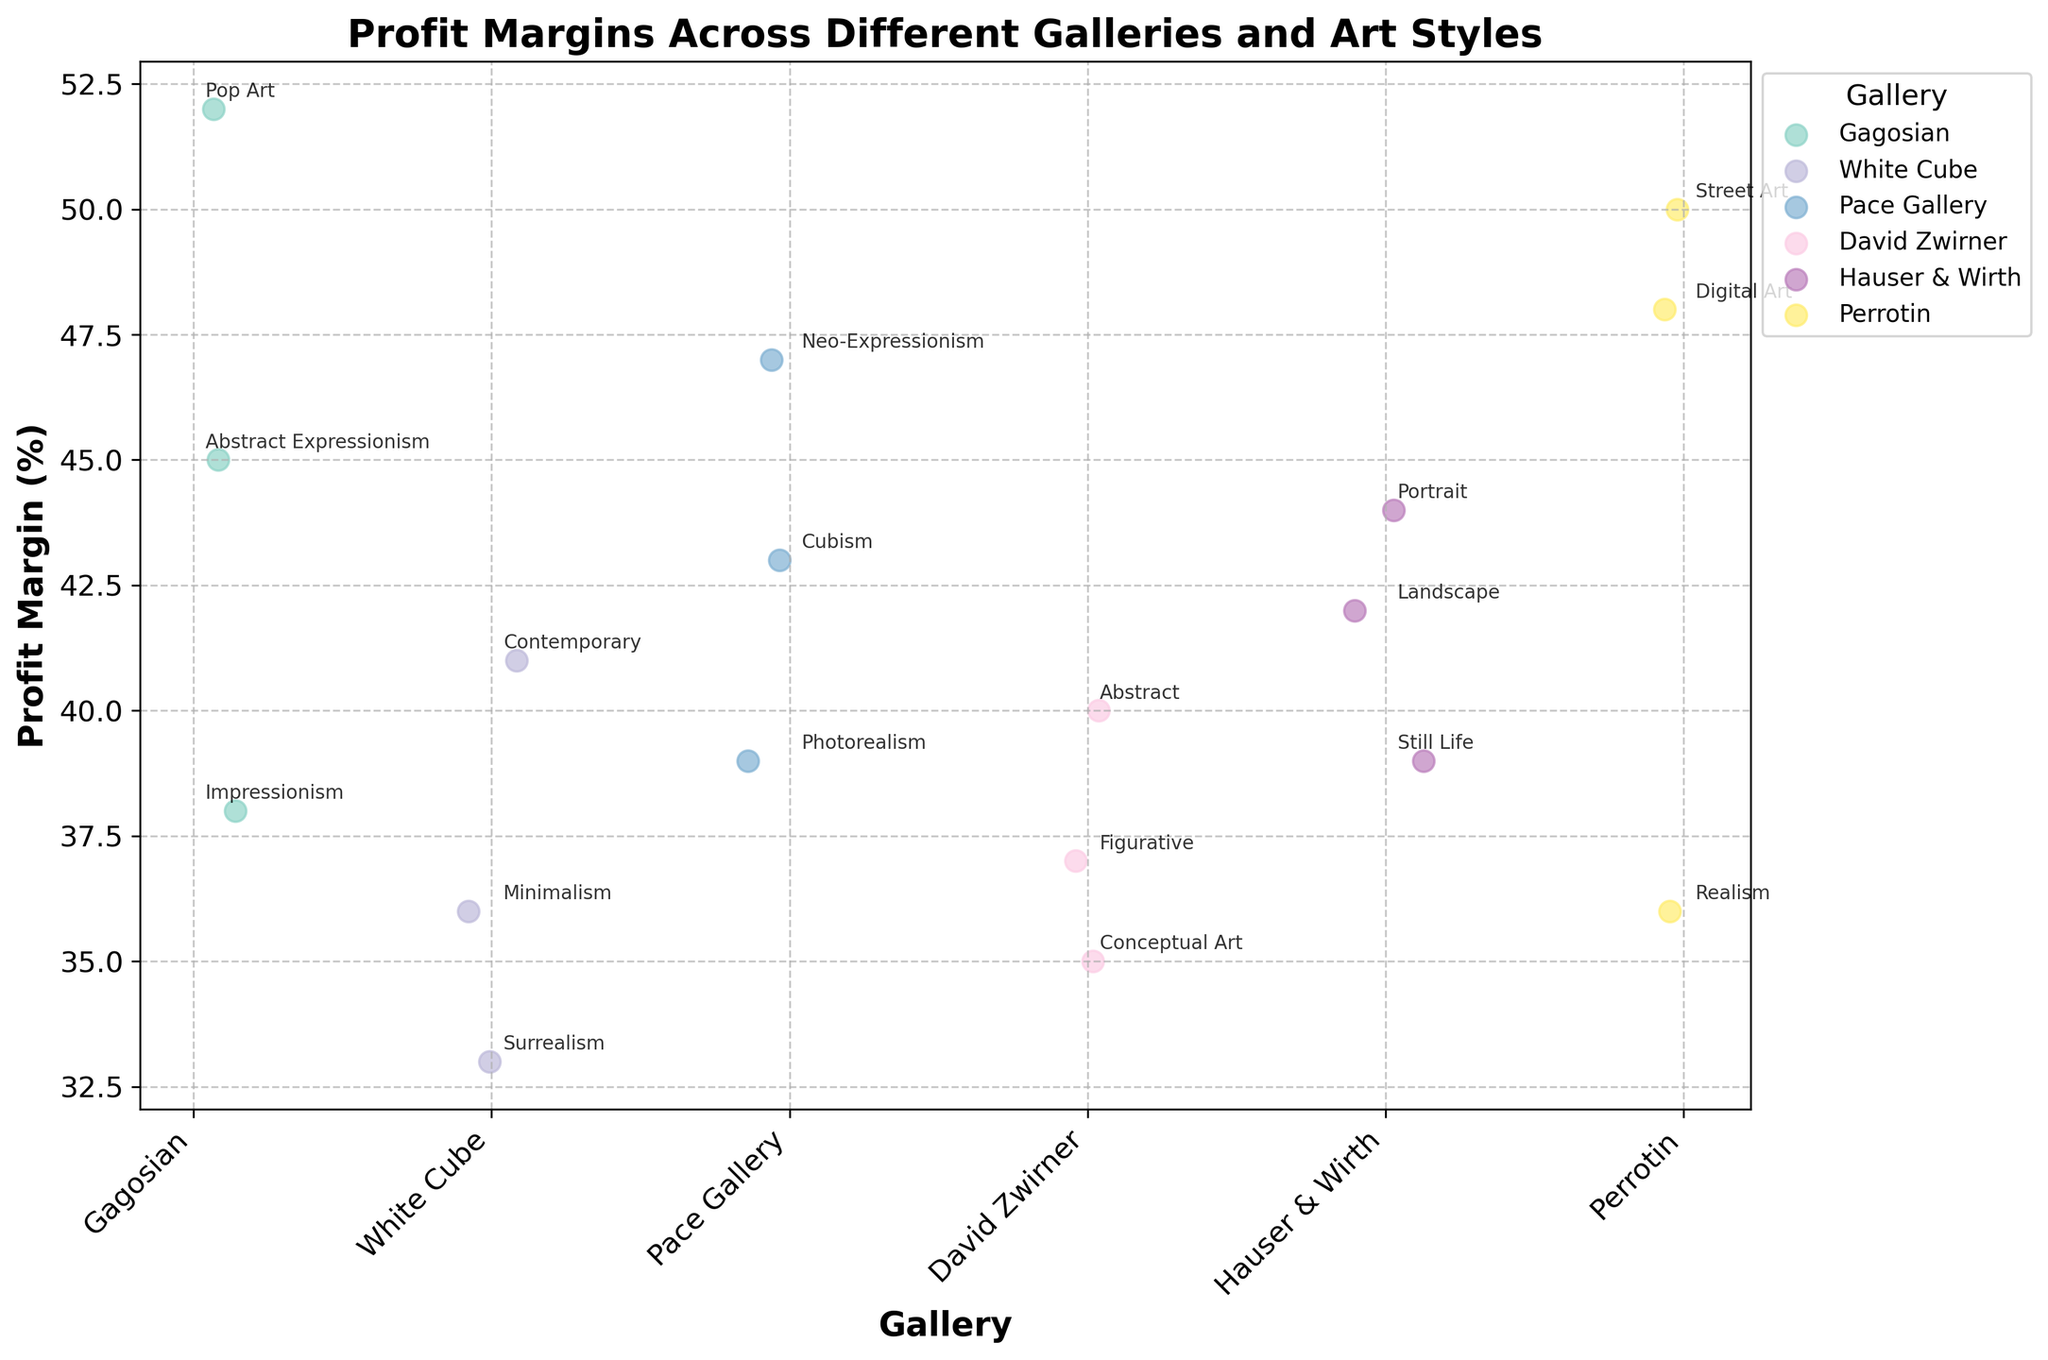what is the title of the plot? The title is written at the top of the plotted figure and bolded.
Answer: Profit Margins Across Different Galleries and Art Styles Which gallery shows the highest profit margin for any painting style? Looking at the data points, the gallery with the highest profit margin (52) is Gagosian, corresponding to Pop Art.
Answer: Gagosian What is the average profit margin for paintings in the Perrotin gallery? The profit margins for Perrotin are 50, 48, and 36. Add them up to get 134, then divide by the number of points (3): 134 / 3 ≈ 44.67.
Answer: 44.67 How does the profit margin for Contemporary art in White Cube compare to the Abstract painting in David Zwirner? The profit margin for Contemporary in White Cube is 41, while for Abstract in David Zwirner it is 40. Thus, the margin for Contemporary is higher by 1.
Answer: Contemporary in White Cube is higher by 1 What is the range of profit margins for paintings in the Hauser & Wirth gallery? The profit margins in Hauser & Wirth are 42, 39, and 44. The range is the difference between the highest and lowest values: 44 - 39 = 5.
Answer: 5 How many galleries have a painting style with a profit margin of 45% or higher? Gagosian (45 for Abstract Expressionism), Hauser & Wirth (44 for Portrait), Perrotin (50 for Street Art, 48 for Digital Art), and Pace Gallery (47 for Neo-Expressionism). Total is 4 galleries.
Answer: 4 Which gallery has the widest variety of painting styles represented? Identifying the number of painting styles for each gallery: Gagosian (3), White Cube (3), Pace Gallery (3), David Zwirner (3), Hauser & Wirth (3), and Perrotin (3). All have the same number of styles represented.
Answer: All have the same number What is the median profit margin for all paintings in the White Cube gallery? Sorting the profit margins (33, 36, 41), the median is the middle value.
Answer: 36 Compare the highest profit margin in Hauser & Wirth to the lowest in Perrotin. The highest in Hauser & Wirth is 44, and the lowest in Perrotin is 36. The difference is 44 - 36 = 8.
Answer: 8 Across all galleries, which painting style has the highest average profit margin? Average the profit margins for each style across all galleries: The highest average is for Pop Art with only one data point of 52.
Answer: Pop Art 